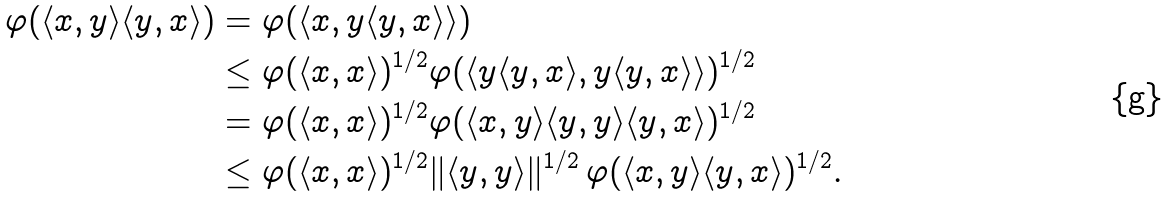<formula> <loc_0><loc_0><loc_500><loc_500>\varphi ( \langle x , y \rangle \langle y , x \rangle ) & = \varphi ( \langle x , y \langle y , x \rangle \rangle ) \\ & \leq \varphi ( \langle x , x \rangle ) ^ { 1 / 2 } \varphi ( \langle y \langle y , x \rangle , y \langle y , x \rangle \rangle ) ^ { 1 / 2 } \\ & = \varphi ( \langle x , x \rangle ) ^ { 1 / 2 } \varphi ( \langle x , y \rangle \langle y , y \rangle \langle y , x \rangle ) ^ { 1 / 2 } \\ & \leq \varphi ( \langle x , x \rangle ) ^ { 1 / 2 } \| \langle y , y \rangle \| ^ { 1 / 2 } \, \varphi ( \langle x , y \rangle \langle y , x \rangle ) ^ { 1 / 2 } .</formula> 